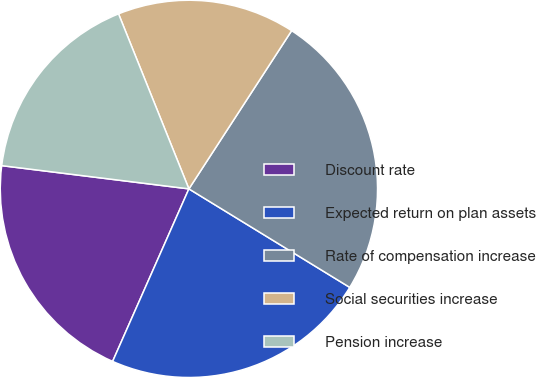Convert chart. <chart><loc_0><loc_0><loc_500><loc_500><pie_chart><fcel>Discount rate<fcel>Expected return on plan assets<fcel>Rate of compensation increase<fcel>Social securities increase<fcel>Pension increase<nl><fcel>20.34%<fcel>22.88%<fcel>24.58%<fcel>15.25%<fcel>16.95%<nl></chart> 